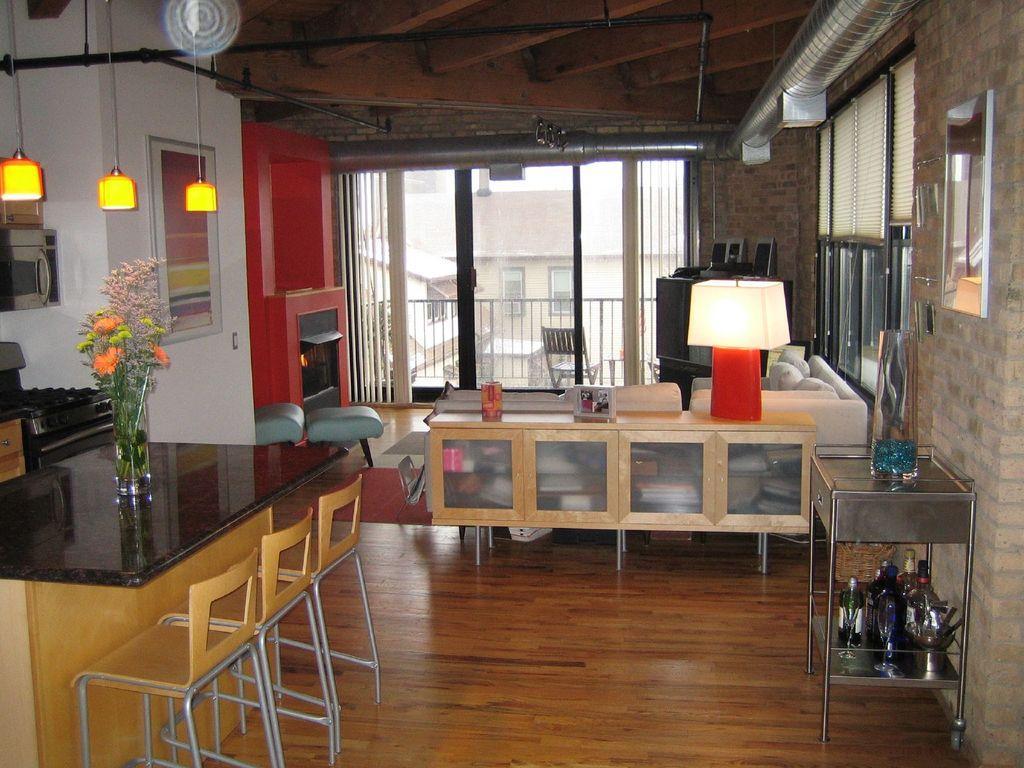Please provide a concise description of this image. In the image we can see there are chairs kept on the floor and there are flowers kept in the vase. There are lights on the top and there are table lamp kept on the table. 